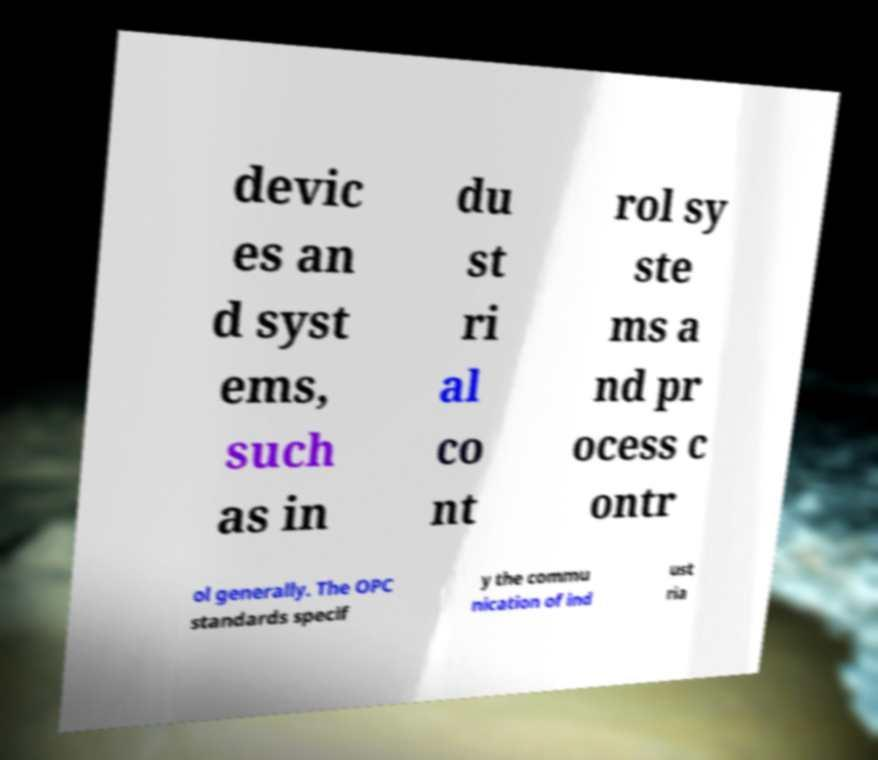Could you extract and type out the text from this image? devic es an d syst ems, such as in du st ri al co nt rol sy ste ms a nd pr ocess c ontr ol generally. The OPC standards specif y the commu nication of ind ust ria 